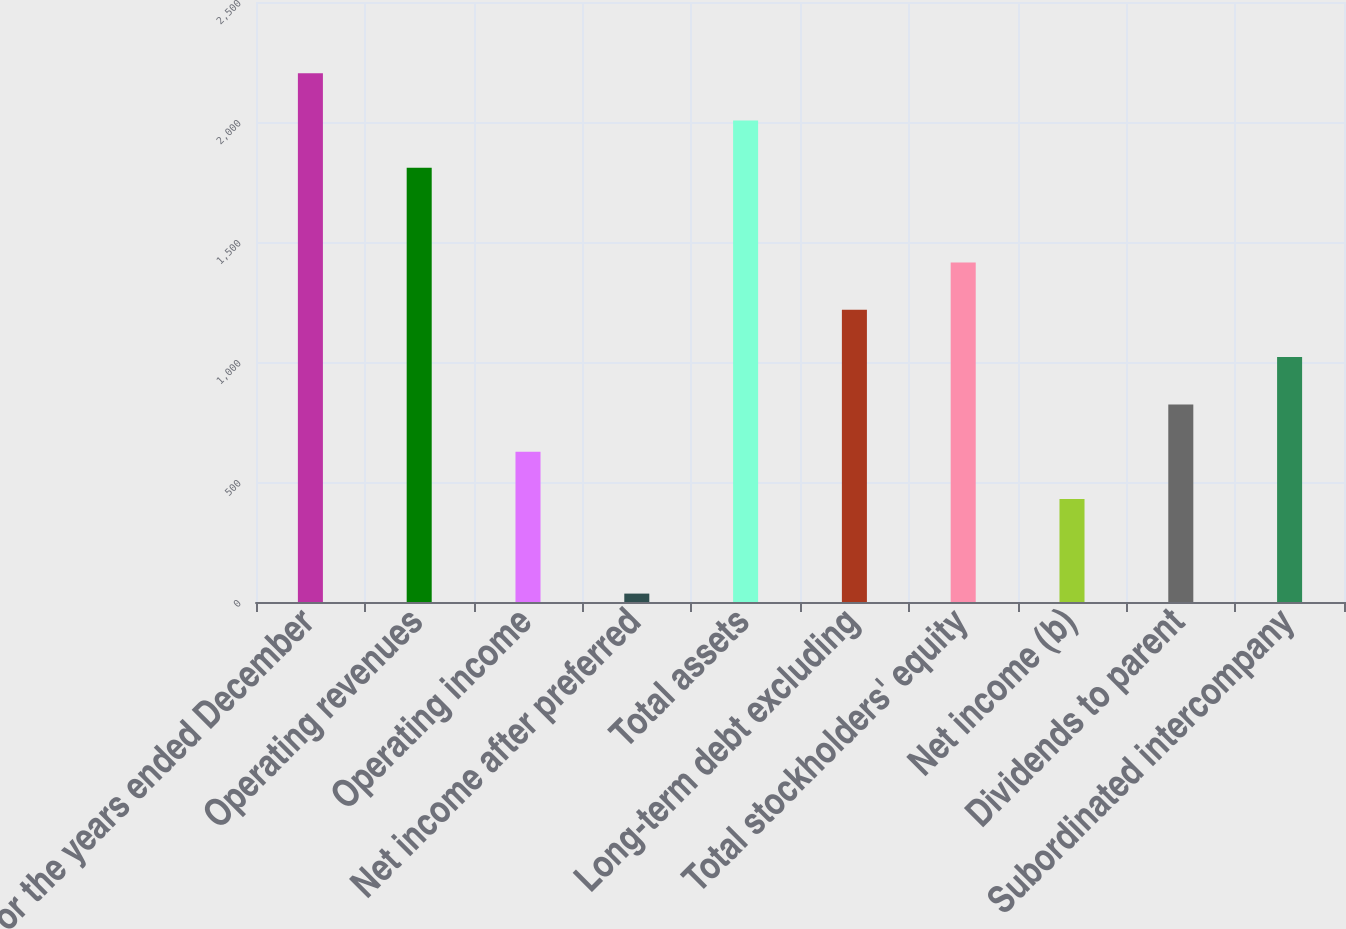Convert chart to OTSL. <chart><loc_0><loc_0><loc_500><loc_500><bar_chart><fcel>For the years ended December<fcel>Operating revenues<fcel>Operating income<fcel>Net income after preferred<fcel>Total assets<fcel>Long-term debt excluding<fcel>Total stockholders' equity<fcel>Net income (b)<fcel>Dividends to parent<fcel>Subordinated intercompany<nl><fcel>2203.1<fcel>1808.9<fcel>626.3<fcel>35<fcel>2006<fcel>1217.6<fcel>1414.7<fcel>429.2<fcel>823.4<fcel>1020.5<nl></chart> 